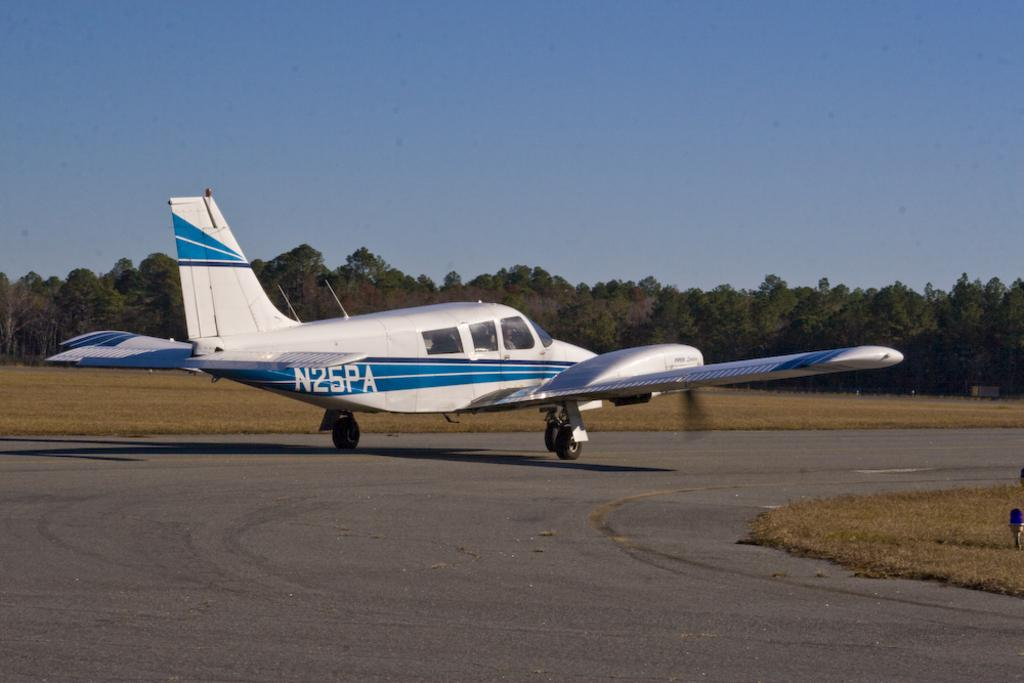<image>
Present a compact description of the photo's key features. A plane is marked N25PA on the side. 